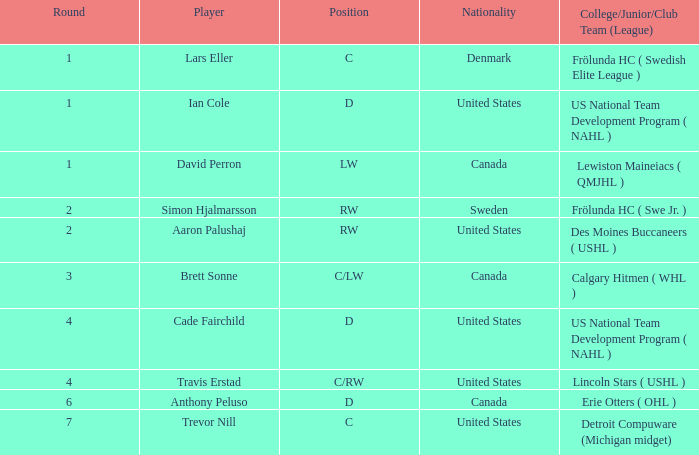What is the maximum round of ian cole, who played position d from the united states? 1.0. 